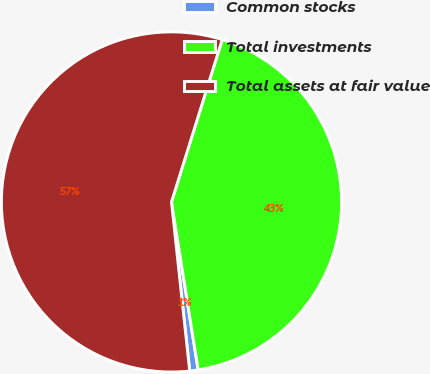Convert chart to OTSL. <chart><loc_0><loc_0><loc_500><loc_500><pie_chart><fcel>Common stocks<fcel>Total investments<fcel>Total assets at fair value<nl><fcel>0.8%<fcel>42.67%<fcel>56.53%<nl></chart> 